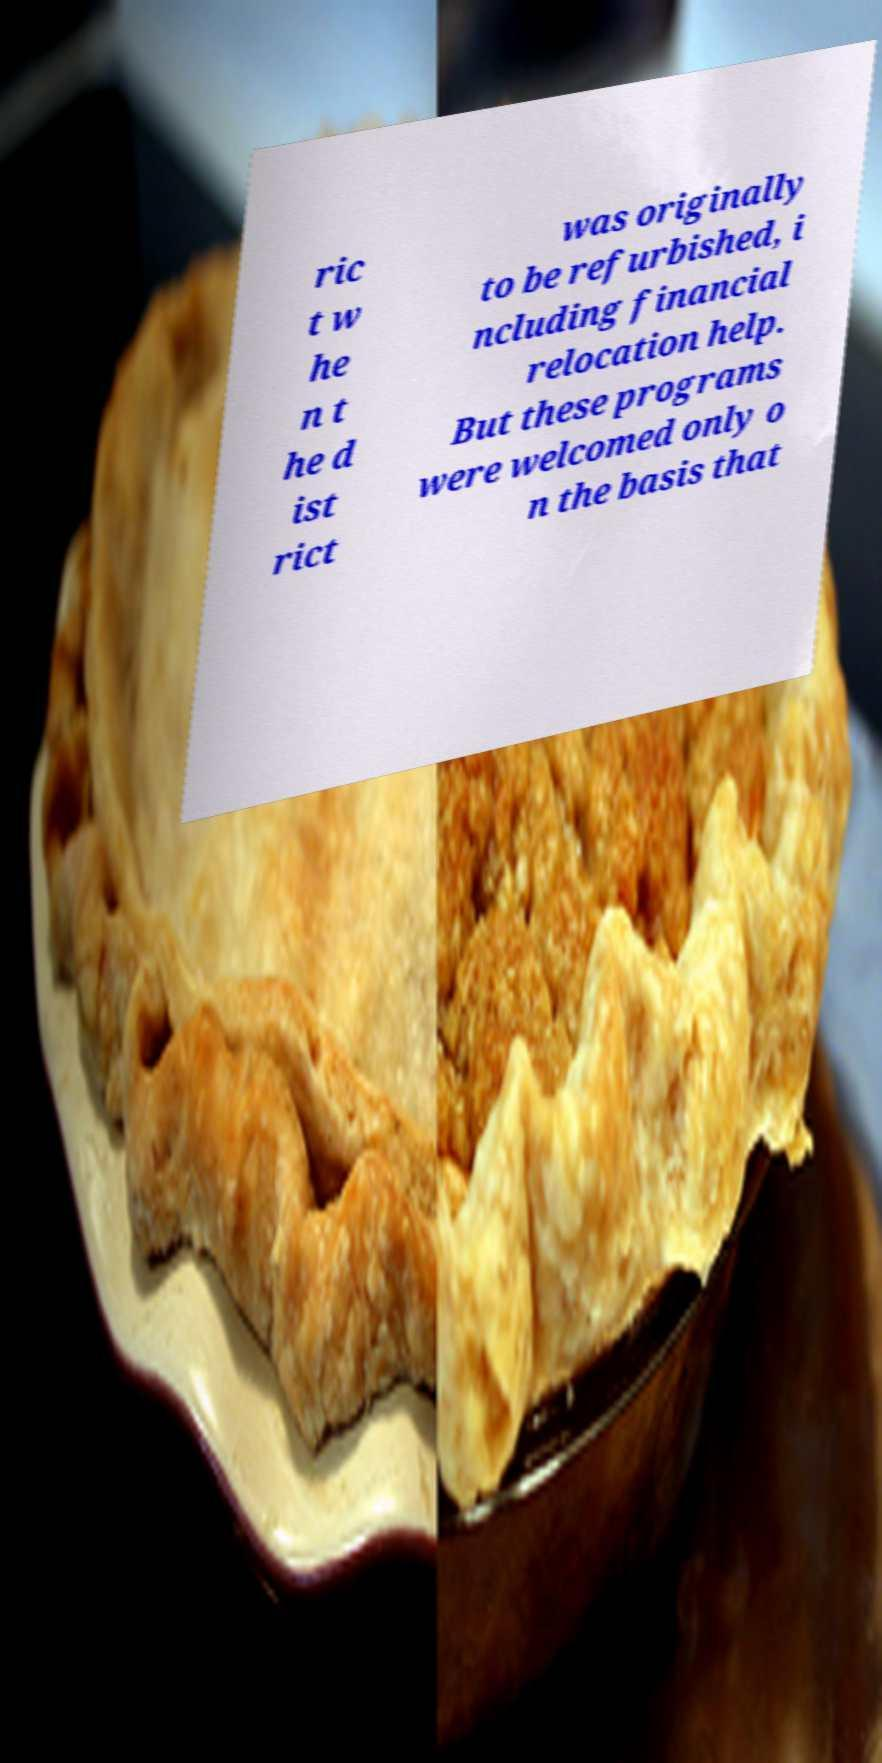Can you read and provide the text displayed in the image?This photo seems to have some interesting text. Can you extract and type it out for me? ric t w he n t he d ist rict was originally to be refurbished, i ncluding financial relocation help. But these programs were welcomed only o n the basis that 